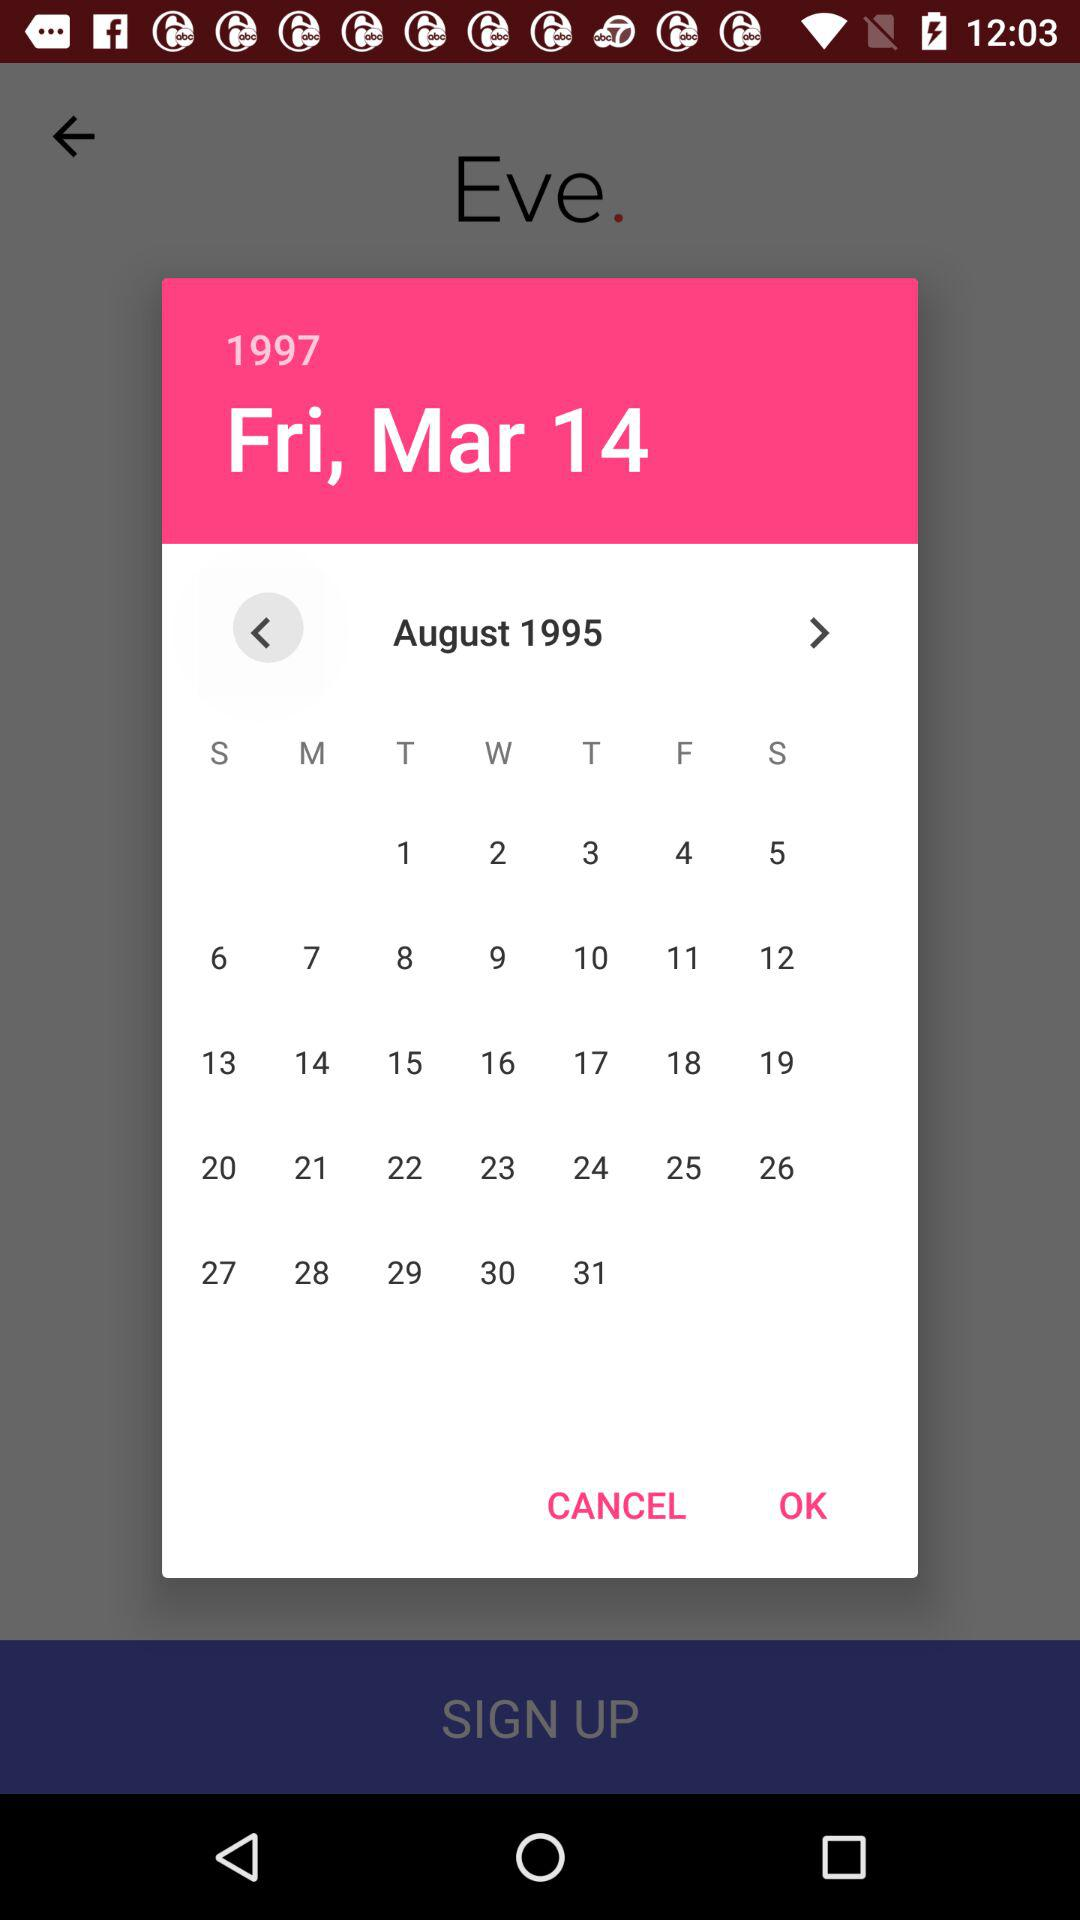What is the selected date? The selected date is Friday, March 14, 1997. 